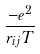Convert formula to latex. <formula><loc_0><loc_0><loc_500><loc_500>\frac { - e ^ { 2 } } { r _ { i j } T }</formula> 